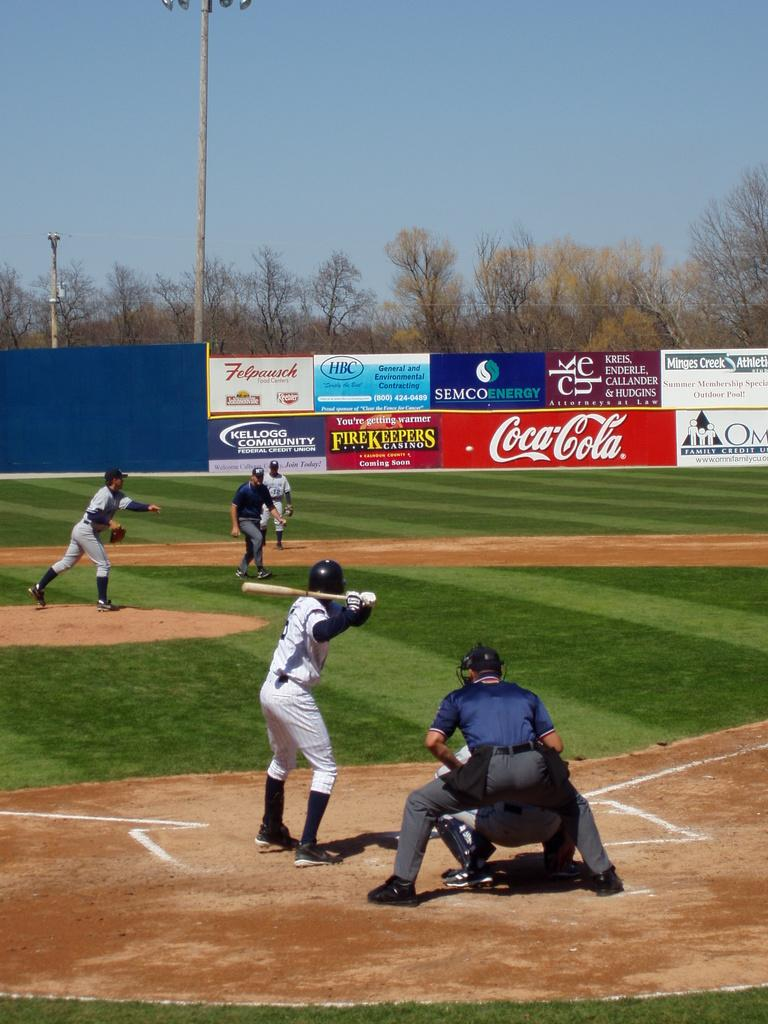<image>
Relay a brief, clear account of the picture shown. Baseball players on a field that is sponsored by Coca-Cola 